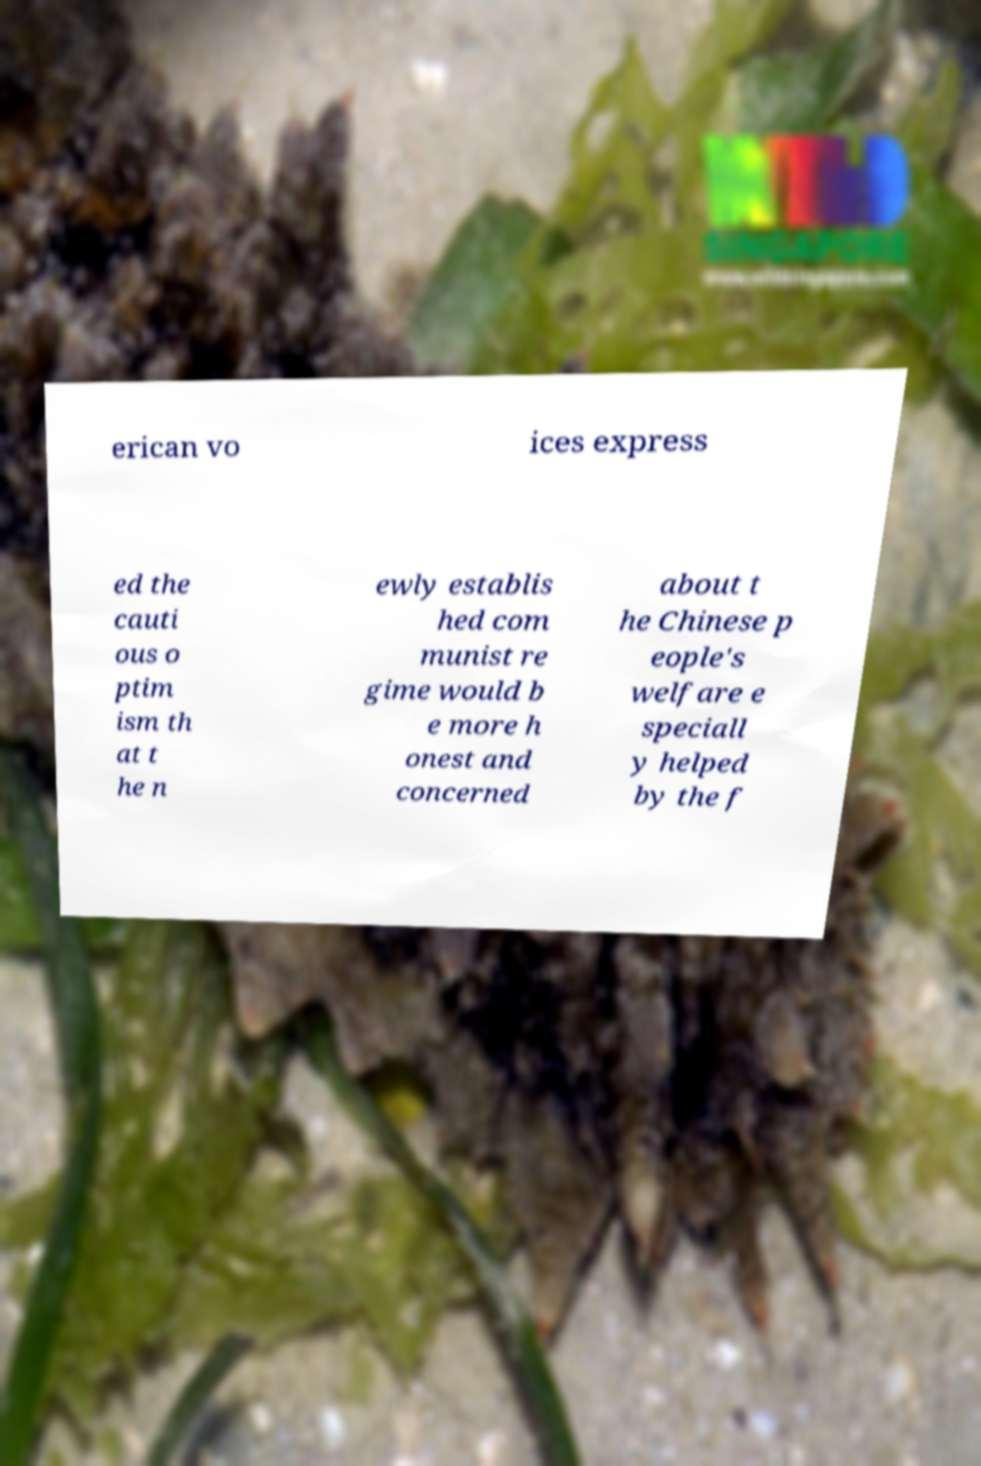I need the written content from this picture converted into text. Can you do that? erican vo ices express ed the cauti ous o ptim ism th at t he n ewly establis hed com munist re gime would b e more h onest and concerned about t he Chinese p eople's welfare e speciall y helped by the f 